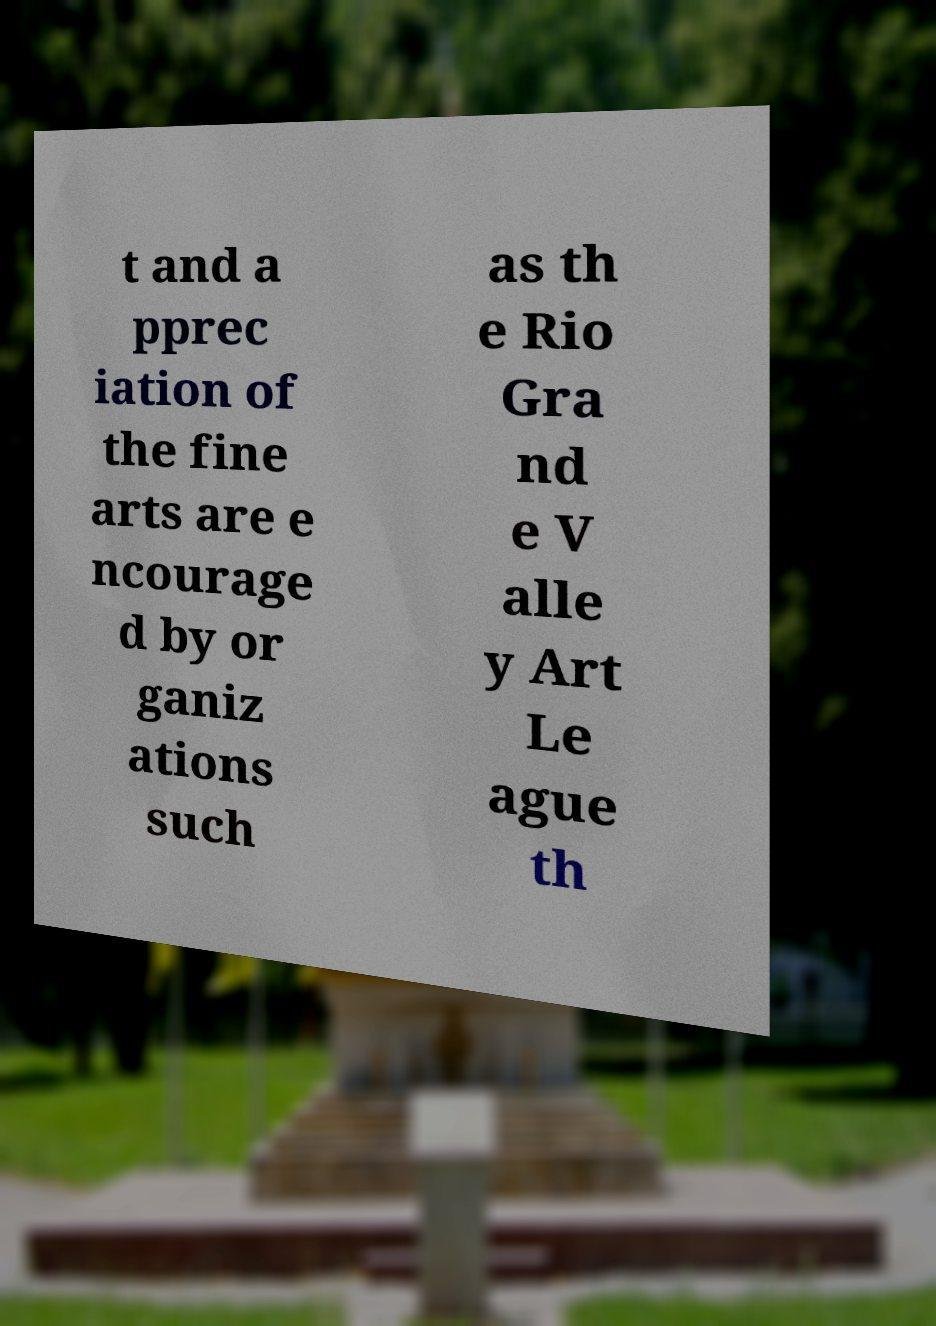Please identify and transcribe the text found in this image. t and a pprec iation of the fine arts are e ncourage d by or ganiz ations such as th e Rio Gra nd e V alle y Art Le ague th 